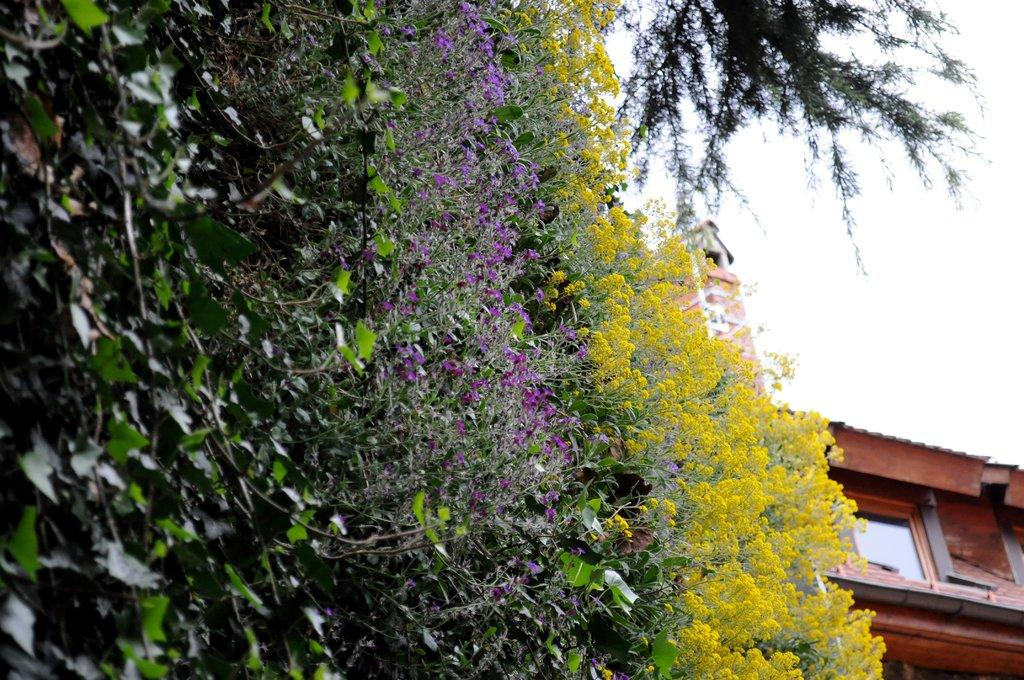What type of vegetation can be seen on the left side of the image? There are flowers on the left side of the image. What else can be seen in the image besides the flowers? There are plants in the image. What type of structure is located on the right side of the image? There is a building on the right side of the image. What type of potato is being traded in the image? There is no potato or any indication of trade present in the image. How many corn plants can be seen in the image? There is no corn plant visible in the image. 